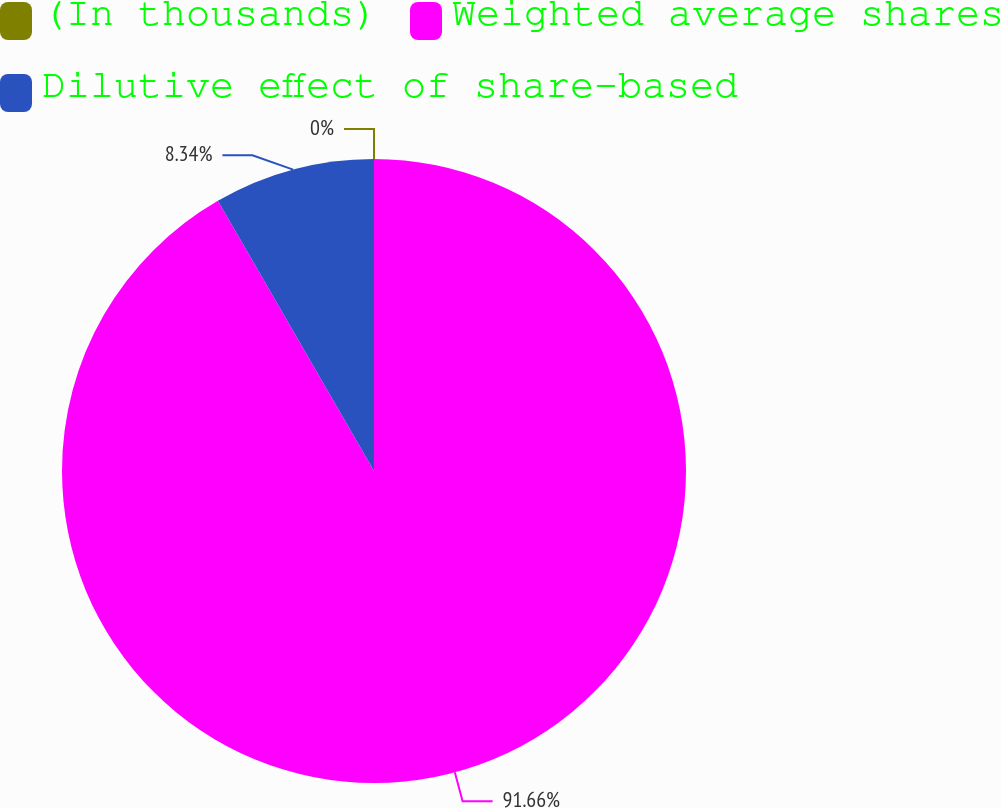<chart> <loc_0><loc_0><loc_500><loc_500><pie_chart><fcel>(In thousands)<fcel>Weighted average shares<fcel>Dilutive effect of share-based<nl><fcel>0.0%<fcel>91.65%<fcel>8.34%<nl></chart> 